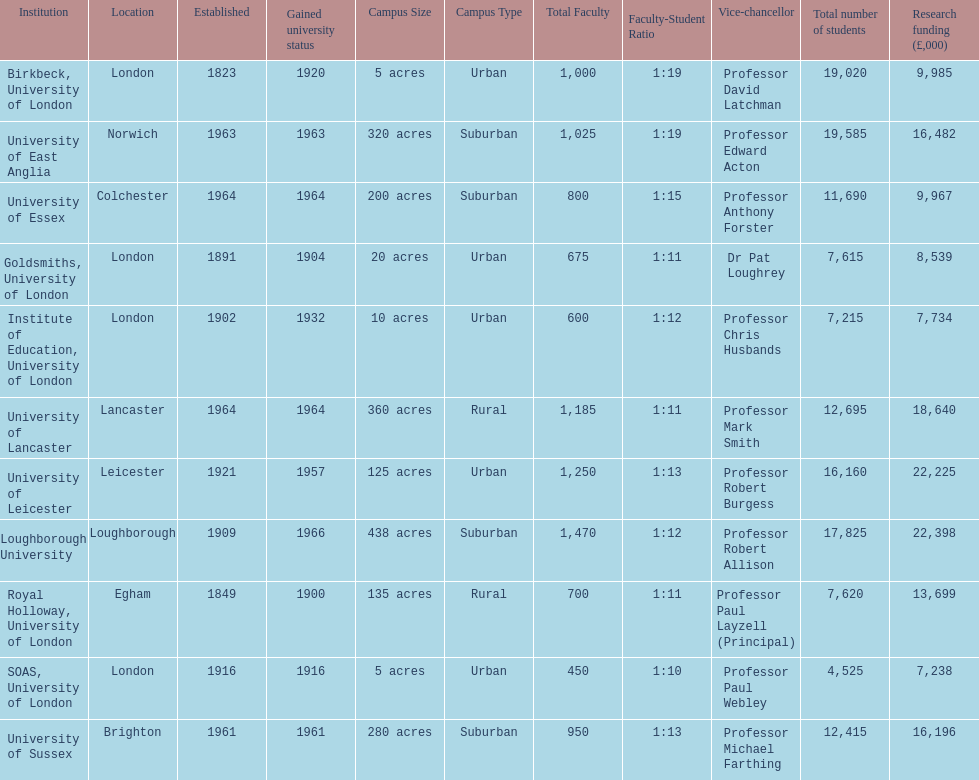How many of the institutions are located in london? 4. 